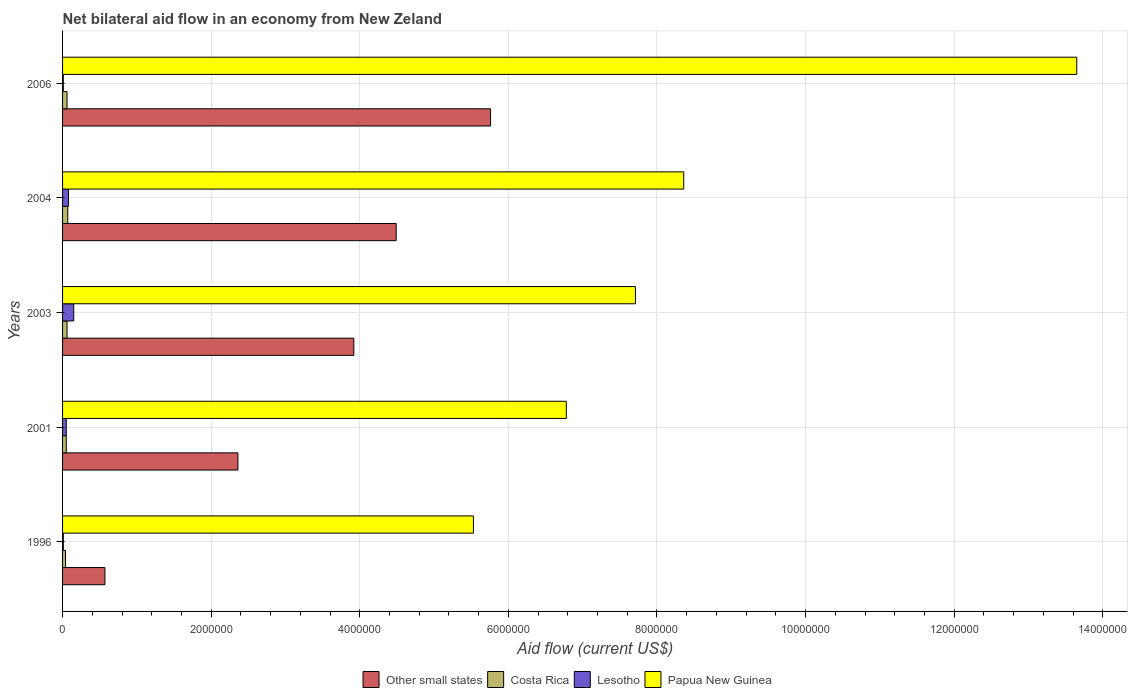How many different coloured bars are there?
Give a very brief answer. 4. Are the number of bars per tick equal to the number of legend labels?
Provide a succinct answer. Yes. Are the number of bars on each tick of the Y-axis equal?
Give a very brief answer. Yes. How many bars are there on the 1st tick from the top?
Your answer should be compact. 4. How many bars are there on the 3rd tick from the bottom?
Make the answer very short. 4. In how many cases, is the number of bars for a given year not equal to the number of legend labels?
Your response must be concise. 0. What is the net bilateral aid flow in Papua New Guinea in 1996?
Keep it short and to the point. 5.53e+06. Across all years, what is the maximum net bilateral aid flow in Other small states?
Make the answer very short. 5.76e+06. Across all years, what is the minimum net bilateral aid flow in Other small states?
Make the answer very short. 5.70e+05. In which year was the net bilateral aid flow in Papua New Guinea minimum?
Make the answer very short. 1996. What is the total net bilateral aid flow in Papua New Guinea in the graph?
Your answer should be very brief. 4.20e+07. What is the difference between the net bilateral aid flow in Papua New Guinea in 2003 and that in 2004?
Your answer should be very brief. -6.50e+05. What is the difference between the net bilateral aid flow in Papua New Guinea in 2006 and the net bilateral aid flow in Costa Rica in 2001?
Make the answer very short. 1.36e+07. What is the average net bilateral aid flow in Other small states per year?
Ensure brevity in your answer.  3.42e+06. In the year 2001, what is the difference between the net bilateral aid flow in Lesotho and net bilateral aid flow in Papua New Guinea?
Give a very brief answer. -6.73e+06. In how many years, is the net bilateral aid flow in Lesotho greater than 800000 US$?
Ensure brevity in your answer.  0. What is the difference between the highest and the second highest net bilateral aid flow in Costa Rica?
Ensure brevity in your answer.  10000. Is it the case that in every year, the sum of the net bilateral aid flow in Lesotho and net bilateral aid flow in Other small states is greater than the sum of net bilateral aid flow in Papua New Guinea and net bilateral aid flow in Costa Rica?
Keep it short and to the point. No. What does the 2nd bar from the top in 2003 represents?
Make the answer very short. Lesotho. What does the 4th bar from the bottom in 2001 represents?
Offer a very short reply. Papua New Guinea. What is the difference between two consecutive major ticks on the X-axis?
Offer a very short reply. 2.00e+06. Are the values on the major ticks of X-axis written in scientific E-notation?
Provide a short and direct response. No. Does the graph contain grids?
Your answer should be very brief. Yes. Where does the legend appear in the graph?
Offer a very short reply. Bottom center. What is the title of the graph?
Offer a terse response. Net bilateral aid flow in an economy from New Zeland. Does "Burkina Faso" appear as one of the legend labels in the graph?
Make the answer very short. No. What is the Aid flow (current US$) in Other small states in 1996?
Offer a terse response. 5.70e+05. What is the Aid flow (current US$) of Costa Rica in 1996?
Your answer should be very brief. 4.00e+04. What is the Aid flow (current US$) of Papua New Guinea in 1996?
Make the answer very short. 5.53e+06. What is the Aid flow (current US$) in Other small states in 2001?
Your answer should be compact. 2.36e+06. What is the Aid flow (current US$) in Costa Rica in 2001?
Your answer should be very brief. 5.00e+04. What is the Aid flow (current US$) of Papua New Guinea in 2001?
Your response must be concise. 6.78e+06. What is the Aid flow (current US$) of Other small states in 2003?
Keep it short and to the point. 3.92e+06. What is the Aid flow (current US$) of Lesotho in 2003?
Your response must be concise. 1.50e+05. What is the Aid flow (current US$) in Papua New Guinea in 2003?
Your answer should be very brief. 7.71e+06. What is the Aid flow (current US$) in Other small states in 2004?
Provide a succinct answer. 4.49e+06. What is the Aid flow (current US$) of Papua New Guinea in 2004?
Make the answer very short. 8.36e+06. What is the Aid flow (current US$) in Other small states in 2006?
Give a very brief answer. 5.76e+06. What is the Aid flow (current US$) of Costa Rica in 2006?
Offer a very short reply. 6.00e+04. What is the Aid flow (current US$) of Papua New Guinea in 2006?
Your answer should be very brief. 1.36e+07. Across all years, what is the maximum Aid flow (current US$) of Other small states?
Offer a very short reply. 5.76e+06. Across all years, what is the maximum Aid flow (current US$) of Lesotho?
Your response must be concise. 1.50e+05. Across all years, what is the maximum Aid flow (current US$) of Papua New Guinea?
Provide a succinct answer. 1.36e+07. Across all years, what is the minimum Aid flow (current US$) of Other small states?
Keep it short and to the point. 5.70e+05. Across all years, what is the minimum Aid flow (current US$) of Costa Rica?
Give a very brief answer. 4.00e+04. Across all years, what is the minimum Aid flow (current US$) of Lesotho?
Provide a short and direct response. 10000. Across all years, what is the minimum Aid flow (current US$) of Papua New Guinea?
Offer a terse response. 5.53e+06. What is the total Aid flow (current US$) of Other small states in the graph?
Ensure brevity in your answer.  1.71e+07. What is the total Aid flow (current US$) in Costa Rica in the graph?
Offer a very short reply. 2.80e+05. What is the total Aid flow (current US$) of Papua New Guinea in the graph?
Give a very brief answer. 4.20e+07. What is the difference between the Aid flow (current US$) of Other small states in 1996 and that in 2001?
Your response must be concise. -1.79e+06. What is the difference between the Aid flow (current US$) in Costa Rica in 1996 and that in 2001?
Make the answer very short. -10000. What is the difference between the Aid flow (current US$) in Papua New Guinea in 1996 and that in 2001?
Give a very brief answer. -1.25e+06. What is the difference between the Aid flow (current US$) of Other small states in 1996 and that in 2003?
Your answer should be very brief. -3.35e+06. What is the difference between the Aid flow (current US$) of Costa Rica in 1996 and that in 2003?
Offer a terse response. -2.00e+04. What is the difference between the Aid flow (current US$) in Papua New Guinea in 1996 and that in 2003?
Provide a succinct answer. -2.18e+06. What is the difference between the Aid flow (current US$) in Other small states in 1996 and that in 2004?
Give a very brief answer. -3.92e+06. What is the difference between the Aid flow (current US$) of Costa Rica in 1996 and that in 2004?
Ensure brevity in your answer.  -3.00e+04. What is the difference between the Aid flow (current US$) of Lesotho in 1996 and that in 2004?
Your answer should be compact. -7.00e+04. What is the difference between the Aid flow (current US$) of Papua New Guinea in 1996 and that in 2004?
Your response must be concise. -2.83e+06. What is the difference between the Aid flow (current US$) in Other small states in 1996 and that in 2006?
Your answer should be very brief. -5.19e+06. What is the difference between the Aid flow (current US$) in Papua New Guinea in 1996 and that in 2006?
Keep it short and to the point. -8.12e+06. What is the difference between the Aid flow (current US$) in Other small states in 2001 and that in 2003?
Your answer should be very brief. -1.56e+06. What is the difference between the Aid flow (current US$) in Costa Rica in 2001 and that in 2003?
Provide a succinct answer. -10000. What is the difference between the Aid flow (current US$) in Lesotho in 2001 and that in 2003?
Keep it short and to the point. -1.00e+05. What is the difference between the Aid flow (current US$) in Papua New Guinea in 2001 and that in 2003?
Provide a short and direct response. -9.30e+05. What is the difference between the Aid flow (current US$) of Other small states in 2001 and that in 2004?
Ensure brevity in your answer.  -2.13e+06. What is the difference between the Aid flow (current US$) in Costa Rica in 2001 and that in 2004?
Your answer should be compact. -2.00e+04. What is the difference between the Aid flow (current US$) in Papua New Guinea in 2001 and that in 2004?
Offer a very short reply. -1.58e+06. What is the difference between the Aid flow (current US$) of Other small states in 2001 and that in 2006?
Keep it short and to the point. -3.40e+06. What is the difference between the Aid flow (current US$) of Costa Rica in 2001 and that in 2006?
Provide a succinct answer. -10000. What is the difference between the Aid flow (current US$) in Lesotho in 2001 and that in 2006?
Offer a very short reply. 4.00e+04. What is the difference between the Aid flow (current US$) of Papua New Guinea in 2001 and that in 2006?
Your response must be concise. -6.87e+06. What is the difference between the Aid flow (current US$) in Other small states in 2003 and that in 2004?
Offer a very short reply. -5.70e+05. What is the difference between the Aid flow (current US$) in Lesotho in 2003 and that in 2004?
Offer a very short reply. 7.00e+04. What is the difference between the Aid flow (current US$) in Papua New Guinea in 2003 and that in 2004?
Your response must be concise. -6.50e+05. What is the difference between the Aid flow (current US$) in Other small states in 2003 and that in 2006?
Provide a succinct answer. -1.84e+06. What is the difference between the Aid flow (current US$) in Costa Rica in 2003 and that in 2006?
Your answer should be very brief. 0. What is the difference between the Aid flow (current US$) in Papua New Guinea in 2003 and that in 2006?
Make the answer very short. -5.94e+06. What is the difference between the Aid flow (current US$) in Other small states in 2004 and that in 2006?
Keep it short and to the point. -1.27e+06. What is the difference between the Aid flow (current US$) in Costa Rica in 2004 and that in 2006?
Keep it short and to the point. 10000. What is the difference between the Aid flow (current US$) of Lesotho in 2004 and that in 2006?
Offer a terse response. 7.00e+04. What is the difference between the Aid flow (current US$) in Papua New Guinea in 2004 and that in 2006?
Provide a short and direct response. -5.29e+06. What is the difference between the Aid flow (current US$) in Other small states in 1996 and the Aid flow (current US$) in Costa Rica in 2001?
Make the answer very short. 5.20e+05. What is the difference between the Aid flow (current US$) in Other small states in 1996 and the Aid flow (current US$) in Lesotho in 2001?
Provide a short and direct response. 5.20e+05. What is the difference between the Aid flow (current US$) of Other small states in 1996 and the Aid flow (current US$) of Papua New Guinea in 2001?
Give a very brief answer. -6.21e+06. What is the difference between the Aid flow (current US$) in Costa Rica in 1996 and the Aid flow (current US$) in Lesotho in 2001?
Your response must be concise. -10000. What is the difference between the Aid flow (current US$) of Costa Rica in 1996 and the Aid flow (current US$) of Papua New Guinea in 2001?
Offer a terse response. -6.74e+06. What is the difference between the Aid flow (current US$) of Lesotho in 1996 and the Aid flow (current US$) of Papua New Guinea in 2001?
Your answer should be compact. -6.77e+06. What is the difference between the Aid flow (current US$) in Other small states in 1996 and the Aid flow (current US$) in Costa Rica in 2003?
Offer a very short reply. 5.10e+05. What is the difference between the Aid flow (current US$) in Other small states in 1996 and the Aid flow (current US$) in Papua New Guinea in 2003?
Make the answer very short. -7.14e+06. What is the difference between the Aid flow (current US$) in Costa Rica in 1996 and the Aid flow (current US$) in Papua New Guinea in 2003?
Offer a terse response. -7.67e+06. What is the difference between the Aid flow (current US$) in Lesotho in 1996 and the Aid flow (current US$) in Papua New Guinea in 2003?
Your answer should be very brief. -7.70e+06. What is the difference between the Aid flow (current US$) of Other small states in 1996 and the Aid flow (current US$) of Lesotho in 2004?
Your answer should be very brief. 4.90e+05. What is the difference between the Aid flow (current US$) of Other small states in 1996 and the Aid flow (current US$) of Papua New Guinea in 2004?
Give a very brief answer. -7.79e+06. What is the difference between the Aid flow (current US$) of Costa Rica in 1996 and the Aid flow (current US$) of Lesotho in 2004?
Provide a succinct answer. -4.00e+04. What is the difference between the Aid flow (current US$) in Costa Rica in 1996 and the Aid flow (current US$) in Papua New Guinea in 2004?
Provide a short and direct response. -8.32e+06. What is the difference between the Aid flow (current US$) of Lesotho in 1996 and the Aid flow (current US$) of Papua New Guinea in 2004?
Provide a succinct answer. -8.35e+06. What is the difference between the Aid flow (current US$) of Other small states in 1996 and the Aid flow (current US$) of Costa Rica in 2006?
Your answer should be compact. 5.10e+05. What is the difference between the Aid flow (current US$) in Other small states in 1996 and the Aid flow (current US$) in Lesotho in 2006?
Ensure brevity in your answer.  5.60e+05. What is the difference between the Aid flow (current US$) in Other small states in 1996 and the Aid flow (current US$) in Papua New Guinea in 2006?
Your answer should be compact. -1.31e+07. What is the difference between the Aid flow (current US$) in Costa Rica in 1996 and the Aid flow (current US$) in Papua New Guinea in 2006?
Ensure brevity in your answer.  -1.36e+07. What is the difference between the Aid flow (current US$) of Lesotho in 1996 and the Aid flow (current US$) of Papua New Guinea in 2006?
Provide a succinct answer. -1.36e+07. What is the difference between the Aid flow (current US$) of Other small states in 2001 and the Aid flow (current US$) of Costa Rica in 2003?
Keep it short and to the point. 2.30e+06. What is the difference between the Aid flow (current US$) in Other small states in 2001 and the Aid flow (current US$) in Lesotho in 2003?
Your response must be concise. 2.21e+06. What is the difference between the Aid flow (current US$) in Other small states in 2001 and the Aid flow (current US$) in Papua New Guinea in 2003?
Ensure brevity in your answer.  -5.35e+06. What is the difference between the Aid flow (current US$) of Costa Rica in 2001 and the Aid flow (current US$) of Papua New Guinea in 2003?
Ensure brevity in your answer.  -7.66e+06. What is the difference between the Aid flow (current US$) of Lesotho in 2001 and the Aid flow (current US$) of Papua New Guinea in 2003?
Make the answer very short. -7.66e+06. What is the difference between the Aid flow (current US$) of Other small states in 2001 and the Aid flow (current US$) of Costa Rica in 2004?
Offer a very short reply. 2.29e+06. What is the difference between the Aid flow (current US$) in Other small states in 2001 and the Aid flow (current US$) in Lesotho in 2004?
Provide a succinct answer. 2.28e+06. What is the difference between the Aid flow (current US$) in Other small states in 2001 and the Aid flow (current US$) in Papua New Guinea in 2004?
Keep it short and to the point. -6.00e+06. What is the difference between the Aid flow (current US$) in Costa Rica in 2001 and the Aid flow (current US$) in Lesotho in 2004?
Ensure brevity in your answer.  -3.00e+04. What is the difference between the Aid flow (current US$) in Costa Rica in 2001 and the Aid flow (current US$) in Papua New Guinea in 2004?
Your response must be concise. -8.31e+06. What is the difference between the Aid flow (current US$) in Lesotho in 2001 and the Aid flow (current US$) in Papua New Guinea in 2004?
Keep it short and to the point. -8.31e+06. What is the difference between the Aid flow (current US$) in Other small states in 2001 and the Aid flow (current US$) in Costa Rica in 2006?
Ensure brevity in your answer.  2.30e+06. What is the difference between the Aid flow (current US$) of Other small states in 2001 and the Aid flow (current US$) of Lesotho in 2006?
Ensure brevity in your answer.  2.35e+06. What is the difference between the Aid flow (current US$) of Other small states in 2001 and the Aid flow (current US$) of Papua New Guinea in 2006?
Provide a succinct answer. -1.13e+07. What is the difference between the Aid flow (current US$) in Costa Rica in 2001 and the Aid flow (current US$) in Lesotho in 2006?
Ensure brevity in your answer.  4.00e+04. What is the difference between the Aid flow (current US$) of Costa Rica in 2001 and the Aid flow (current US$) of Papua New Guinea in 2006?
Ensure brevity in your answer.  -1.36e+07. What is the difference between the Aid flow (current US$) of Lesotho in 2001 and the Aid flow (current US$) of Papua New Guinea in 2006?
Your answer should be very brief. -1.36e+07. What is the difference between the Aid flow (current US$) in Other small states in 2003 and the Aid flow (current US$) in Costa Rica in 2004?
Offer a very short reply. 3.85e+06. What is the difference between the Aid flow (current US$) of Other small states in 2003 and the Aid flow (current US$) of Lesotho in 2004?
Make the answer very short. 3.84e+06. What is the difference between the Aid flow (current US$) of Other small states in 2003 and the Aid flow (current US$) of Papua New Guinea in 2004?
Make the answer very short. -4.44e+06. What is the difference between the Aid flow (current US$) of Costa Rica in 2003 and the Aid flow (current US$) of Lesotho in 2004?
Give a very brief answer. -2.00e+04. What is the difference between the Aid flow (current US$) of Costa Rica in 2003 and the Aid flow (current US$) of Papua New Guinea in 2004?
Your response must be concise. -8.30e+06. What is the difference between the Aid flow (current US$) of Lesotho in 2003 and the Aid flow (current US$) of Papua New Guinea in 2004?
Your answer should be very brief. -8.21e+06. What is the difference between the Aid flow (current US$) in Other small states in 2003 and the Aid flow (current US$) in Costa Rica in 2006?
Offer a terse response. 3.86e+06. What is the difference between the Aid flow (current US$) in Other small states in 2003 and the Aid flow (current US$) in Lesotho in 2006?
Offer a terse response. 3.91e+06. What is the difference between the Aid flow (current US$) in Other small states in 2003 and the Aid flow (current US$) in Papua New Guinea in 2006?
Your response must be concise. -9.73e+06. What is the difference between the Aid flow (current US$) of Costa Rica in 2003 and the Aid flow (current US$) of Papua New Guinea in 2006?
Give a very brief answer. -1.36e+07. What is the difference between the Aid flow (current US$) in Lesotho in 2003 and the Aid flow (current US$) in Papua New Guinea in 2006?
Provide a succinct answer. -1.35e+07. What is the difference between the Aid flow (current US$) in Other small states in 2004 and the Aid flow (current US$) in Costa Rica in 2006?
Your answer should be very brief. 4.43e+06. What is the difference between the Aid flow (current US$) of Other small states in 2004 and the Aid flow (current US$) of Lesotho in 2006?
Keep it short and to the point. 4.48e+06. What is the difference between the Aid flow (current US$) of Other small states in 2004 and the Aid flow (current US$) of Papua New Guinea in 2006?
Provide a short and direct response. -9.16e+06. What is the difference between the Aid flow (current US$) of Costa Rica in 2004 and the Aid flow (current US$) of Lesotho in 2006?
Your answer should be very brief. 6.00e+04. What is the difference between the Aid flow (current US$) in Costa Rica in 2004 and the Aid flow (current US$) in Papua New Guinea in 2006?
Offer a very short reply. -1.36e+07. What is the difference between the Aid flow (current US$) of Lesotho in 2004 and the Aid flow (current US$) of Papua New Guinea in 2006?
Offer a terse response. -1.36e+07. What is the average Aid flow (current US$) in Other small states per year?
Offer a terse response. 3.42e+06. What is the average Aid flow (current US$) in Costa Rica per year?
Offer a terse response. 5.60e+04. What is the average Aid flow (current US$) of Lesotho per year?
Your answer should be compact. 6.00e+04. What is the average Aid flow (current US$) in Papua New Guinea per year?
Ensure brevity in your answer.  8.41e+06. In the year 1996, what is the difference between the Aid flow (current US$) in Other small states and Aid flow (current US$) in Costa Rica?
Your answer should be very brief. 5.30e+05. In the year 1996, what is the difference between the Aid flow (current US$) in Other small states and Aid flow (current US$) in Lesotho?
Provide a succinct answer. 5.60e+05. In the year 1996, what is the difference between the Aid flow (current US$) of Other small states and Aid flow (current US$) of Papua New Guinea?
Offer a very short reply. -4.96e+06. In the year 1996, what is the difference between the Aid flow (current US$) of Costa Rica and Aid flow (current US$) of Papua New Guinea?
Provide a succinct answer. -5.49e+06. In the year 1996, what is the difference between the Aid flow (current US$) in Lesotho and Aid flow (current US$) in Papua New Guinea?
Offer a terse response. -5.52e+06. In the year 2001, what is the difference between the Aid flow (current US$) of Other small states and Aid flow (current US$) of Costa Rica?
Ensure brevity in your answer.  2.31e+06. In the year 2001, what is the difference between the Aid flow (current US$) of Other small states and Aid flow (current US$) of Lesotho?
Ensure brevity in your answer.  2.31e+06. In the year 2001, what is the difference between the Aid flow (current US$) in Other small states and Aid flow (current US$) in Papua New Guinea?
Provide a short and direct response. -4.42e+06. In the year 2001, what is the difference between the Aid flow (current US$) in Costa Rica and Aid flow (current US$) in Lesotho?
Provide a short and direct response. 0. In the year 2001, what is the difference between the Aid flow (current US$) in Costa Rica and Aid flow (current US$) in Papua New Guinea?
Give a very brief answer. -6.73e+06. In the year 2001, what is the difference between the Aid flow (current US$) in Lesotho and Aid flow (current US$) in Papua New Guinea?
Keep it short and to the point. -6.73e+06. In the year 2003, what is the difference between the Aid flow (current US$) in Other small states and Aid flow (current US$) in Costa Rica?
Your response must be concise. 3.86e+06. In the year 2003, what is the difference between the Aid flow (current US$) in Other small states and Aid flow (current US$) in Lesotho?
Ensure brevity in your answer.  3.77e+06. In the year 2003, what is the difference between the Aid flow (current US$) of Other small states and Aid flow (current US$) of Papua New Guinea?
Offer a very short reply. -3.79e+06. In the year 2003, what is the difference between the Aid flow (current US$) of Costa Rica and Aid flow (current US$) of Papua New Guinea?
Your answer should be very brief. -7.65e+06. In the year 2003, what is the difference between the Aid flow (current US$) in Lesotho and Aid flow (current US$) in Papua New Guinea?
Your response must be concise. -7.56e+06. In the year 2004, what is the difference between the Aid flow (current US$) of Other small states and Aid flow (current US$) of Costa Rica?
Offer a very short reply. 4.42e+06. In the year 2004, what is the difference between the Aid flow (current US$) in Other small states and Aid flow (current US$) in Lesotho?
Provide a succinct answer. 4.41e+06. In the year 2004, what is the difference between the Aid flow (current US$) in Other small states and Aid flow (current US$) in Papua New Guinea?
Make the answer very short. -3.87e+06. In the year 2004, what is the difference between the Aid flow (current US$) in Costa Rica and Aid flow (current US$) in Papua New Guinea?
Keep it short and to the point. -8.29e+06. In the year 2004, what is the difference between the Aid flow (current US$) of Lesotho and Aid flow (current US$) of Papua New Guinea?
Give a very brief answer. -8.28e+06. In the year 2006, what is the difference between the Aid flow (current US$) of Other small states and Aid flow (current US$) of Costa Rica?
Make the answer very short. 5.70e+06. In the year 2006, what is the difference between the Aid flow (current US$) in Other small states and Aid flow (current US$) in Lesotho?
Your response must be concise. 5.75e+06. In the year 2006, what is the difference between the Aid flow (current US$) in Other small states and Aid flow (current US$) in Papua New Guinea?
Make the answer very short. -7.89e+06. In the year 2006, what is the difference between the Aid flow (current US$) of Costa Rica and Aid flow (current US$) of Papua New Guinea?
Your answer should be very brief. -1.36e+07. In the year 2006, what is the difference between the Aid flow (current US$) in Lesotho and Aid flow (current US$) in Papua New Guinea?
Offer a very short reply. -1.36e+07. What is the ratio of the Aid flow (current US$) in Other small states in 1996 to that in 2001?
Offer a very short reply. 0.24. What is the ratio of the Aid flow (current US$) of Lesotho in 1996 to that in 2001?
Your response must be concise. 0.2. What is the ratio of the Aid flow (current US$) in Papua New Guinea in 1996 to that in 2001?
Your answer should be very brief. 0.82. What is the ratio of the Aid flow (current US$) in Other small states in 1996 to that in 2003?
Keep it short and to the point. 0.15. What is the ratio of the Aid flow (current US$) of Lesotho in 1996 to that in 2003?
Provide a succinct answer. 0.07. What is the ratio of the Aid flow (current US$) of Papua New Guinea in 1996 to that in 2003?
Provide a succinct answer. 0.72. What is the ratio of the Aid flow (current US$) in Other small states in 1996 to that in 2004?
Your response must be concise. 0.13. What is the ratio of the Aid flow (current US$) in Costa Rica in 1996 to that in 2004?
Provide a succinct answer. 0.57. What is the ratio of the Aid flow (current US$) in Papua New Guinea in 1996 to that in 2004?
Offer a very short reply. 0.66. What is the ratio of the Aid flow (current US$) in Other small states in 1996 to that in 2006?
Your response must be concise. 0.1. What is the ratio of the Aid flow (current US$) in Lesotho in 1996 to that in 2006?
Your answer should be compact. 1. What is the ratio of the Aid flow (current US$) of Papua New Guinea in 1996 to that in 2006?
Make the answer very short. 0.41. What is the ratio of the Aid flow (current US$) in Other small states in 2001 to that in 2003?
Offer a terse response. 0.6. What is the ratio of the Aid flow (current US$) in Costa Rica in 2001 to that in 2003?
Your answer should be compact. 0.83. What is the ratio of the Aid flow (current US$) of Lesotho in 2001 to that in 2003?
Give a very brief answer. 0.33. What is the ratio of the Aid flow (current US$) of Papua New Guinea in 2001 to that in 2003?
Provide a succinct answer. 0.88. What is the ratio of the Aid flow (current US$) of Other small states in 2001 to that in 2004?
Keep it short and to the point. 0.53. What is the ratio of the Aid flow (current US$) of Costa Rica in 2001 to that in 2004?
Your response must be concise. 0.71. What is the ratio of the Aid flow (current US$) in Lesotho in 2001 to that in 2004?
Your answer should be very brief. 0.62. What is the ratio of the Aid flow (current US$) of Papua New Guinea in 2001 to that in 2004?
Your response must be concise. 0.81. What is the ratio of the Aid flow (current US$) in Other small states in 2001 to that in 2006?
Make the answer very short. 0.41. What is the ratio of the Aid flow (current US$) in Costa Rica in 2001 to that in 2006?
Ensure brevity in your answer.  0.83. What is the ratio of the Aid flow (current US$) in Papua New Guinea in 2001 to that in 2006?
Your response must be concise. 0.5. What is the ratio of the Aid flow (current US$) in Other small states in 2003 to that in 2004?
Offer a terse response. 0.87. What is the ratio of the Aid flow (current US$) of Lesotho in 2003 to that in 2004?
Ensure brevity in your answer.  1.88. What is the ratio of the Aid flow (current US$) of Papua New Guinea in 2003 to that in 2004?
Provide a short and direct response. 0.92. What is the ratio of the Aid flow (current US$) in Other small states in 2003 to that in 2006?
Provide a succinct answer. 0.68. What is the ratio of the Aid flow (current US$) of Lesotho in 2003 to that in 2006?
Your answer should be very brief. 15. What is the ratio of the Aid flow (current US$) in Papua New Guinea in 2003 to that in 2006?
Provide a succinct answer. 0.56. What is the ratio of the Aid flow (current US$) in Other small states in 2004 to that in 2006?
Offer a terse response. 0.78. What is the ratio of the Aid flow (current US$) in Costa Rica in 2004 to that in 2006?
Offer a terse response. 1.17. What is the ratio of the Aid flow (current US$) of Lesotho in 2004 to that in 2006?
Ensure brevity in your answer.  8. What is the ratio of the Aid flow (current US$) in Papua New Guinea in 2004 to that in 2006?
Keep it short and to the point. 0.61. What is the difference between the highest and the second highest Aid flow (current US$) of Other small states?
Keep it short and to the point. 1.27e+06. What is the difference between the highest and the second highest Aid flow (current US$) of Papua New Guinea?
Offer a terse response. 5.29e+06. What is the difference between the highest and the lowest Aid flow (current US$) in Other small states?
Provide a short and direct response. 5.19e+06. What is the difference between the highest and the lowest Aid flow (current US$) of Papua New Guinea?
Ensure brevity in your answer.  8.12e+06. 